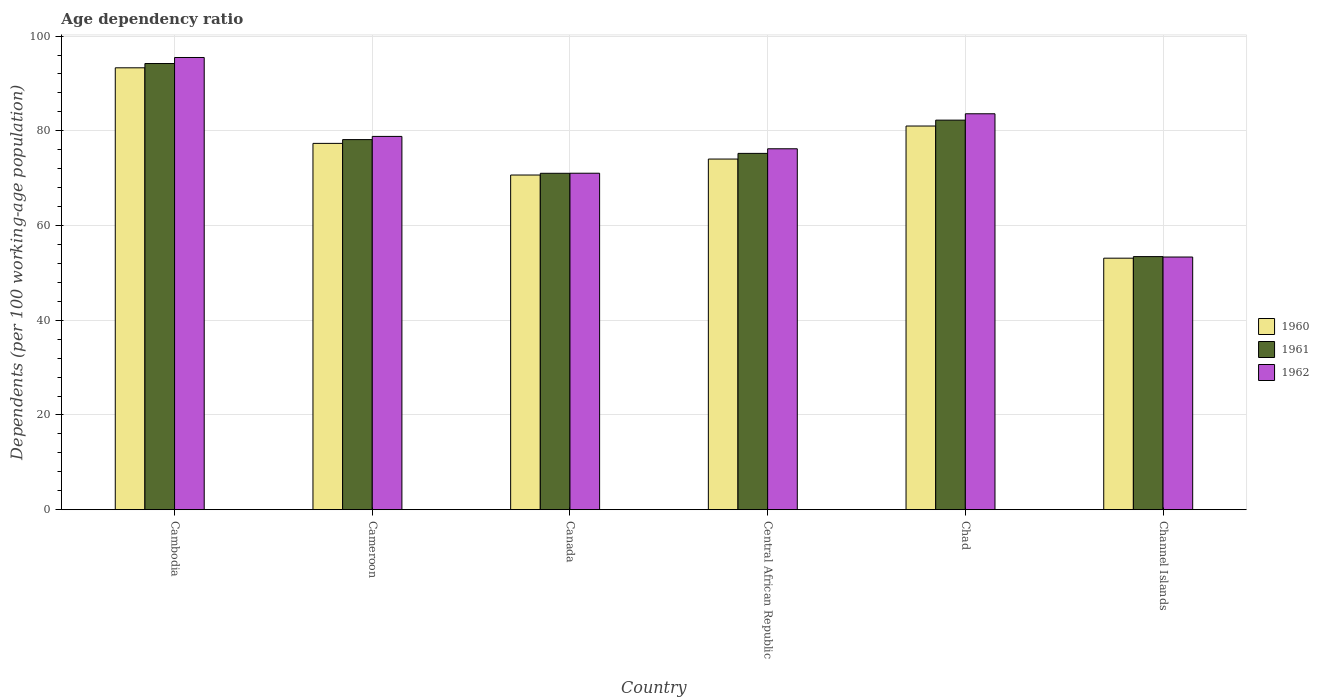How many groups of bars are there?
Ensure brevity in your answer.  6. Are the number of bars per tick equal to the number of legend labels?
Make the answer very short. Yes. How many bars are there on the 2nd tick from the left?
Provide a short and direct response. 3. How many bars are there on the 1st tick from the right?
Your answer should be very brief. 3. What is the label of the 5th group of bars from the left?
Your answer should be very brief. Chad. What is the age dependency ratio in in 1960 in Cambodia?
Your answer should be very brief. 93.3. Across all countries, what is the maximum age dependency ratio in in 1960?
Your answer should be compact. 93.3. Across all countries, what is the minimum age dependency ratio in in 1962?
Ensure brevity in your answer.  53.35. In which country was the age dependency ratio in in 1962 maximum?
Give a very brief answer. Cambodia. In which country was the age dependency ratio in in 1962 minimum?
Your response must be concise. Channel Islands. What is the total age dependency ratio in in 1962 in the graph?
Provide a succinct answer. 458.49. What is the difference between the age dependency ratio in in 1960 in Cambodia and that in Channel Islands?
Provide a succinct answer. 40.2. What is the difference between the age dependency ratio in in 1960 in Cambodia and the age dependency ratio in in 1962 in Canada?
Ensure brevity in your answer.  22.26. What is the average age dependency ratio in in 1962 per country?
Your answer should be very brief. 76.41. What is the difference between the age dependency ratio in of/in 1961 and age dependency ratio in of/in 1962 in Central African Republic?
Your response must be concise. -0.97. In how many countries, is the age dependency ratio in in 1961 greater than 64 %?
Make the answer very short. 5. What is the ratio of the age dependency ratio in in 1961 in Central African Republic to that in Chad?
Provide a succinct answer. 0.91. Is the age dependency ratio in in 1960 in Canada less than that in Chad?
Provide a short and direct response. Yes. What is the difference between the highest and the second highest age dependency ratio in in 1962?
Make the answer very short. 4.78. What is the difference between the highest and the lowest age dependency ratio in in 1962?
Your answer should be very brief. 42.13. Is the sum of the age dependency ratio in in 1961 in Cambodia and Chad greater than the maximum age dependency ratio in in 1960 across all countries?
Your response must be concise. Yes. What does the 2nd bar from the left in Channel Islands represents?
Your answer should be very brief. 1961. Is it the case that in every country, the sum of the age dependency ratio in in 1961 and age dependency ratio in in 1960 is greater than the age dependency ratio in in 1962?
Your answer should be very brief. Yes. Are the values on the major ticks of Y-axis written in scientific E-notation?
Ensure brevity in your answer.  No. How are the legend labels stacked?
Provide a succinct answer. Vertical. What is the title of the graph?
Provide a succinct answer. Age dependency ratio. Does "1961" appear as one of the legend labels in the graph?
Provide a succinct answer. Yes. What is the label or title of the Y-axis?
Make the answer very short. Dependents (per 100 working-age population). What is the Dependents (per 100 working-age population) of 1960 in Cambodia?
Offer a very short reply. 93.3. What is the Dependents (per 100 working-age population) in 1961 in Cambodia?
Offer a terse response. 94.21. What is the Dependents (per 100 working-age population) in 1962 in Cambodia?
Give a very brief answer. 95.48. What is the Dependents (per 100 working-age population) in 1960 in Cameroon?
Give a very brief answer. 77.34. What is the Dependents (per 100 working-age population) in 1961 in Cameroon?
Keep it short and to the point. 78.14. What is the Dependents (per 100 working-age population) of 1962 in Cameroon?
Offer a terse response. 78.82. What is the Dependents (per 100 working-age population) of 1960 in Canada?
Your response must be concise. 70.66. What is the Dependents (per 100 working-age population) in 1961 in Canada?
Offer a very short reply. 71.03. What is the Dependents (per 100 working-age population) of 1962 in Canada?
Your answer should be compact. 71.04. What is the Dependents (per 100 working-age population) of 1960 in Central African Republic?
Provide a short and direct response. 74.03. What is the Dependents (per 100 working-age population) of 1961 in Central African Republic?
Make the answer very short. 75.23. What is the Dependents (per 100 working-age population) in 1962 in Central African Republic?
Offer a very short reply. 76.21. What is the Dependents (per 100 working-age population) of 1960 in Chad?
Provide a succinct answer. 81.01. What is the Dependents (per 100 working-age population) of 1961 in Chad?
Your response must be concise. 82.25. What is the Dependents (per 100 working-age population) of 1962 in Chad?
Provide a short and direct response. 83.6. What is the Dependents (per 100 working-age population) in 1960 in Channel Islands?
Give a very brief answer. 53.1. What is the Dependents (per 100 working-age population) in 1961 in Channel Islands?
Offer a very short reply. 53.44. What is the Dependents (per 100 working-age population) in 1962 in Channel Islands?
Keep it short and to the point. 53.35. Across all countries, what is the maximum Dependents (per 100 working-age population) of 1960?
Keep it short and to the point. 93.3. Across all countries, what is the maximum Dependents (per 100 working-age population) of 1961?
Ensure brevity in your answer.  94.21. Across all countries, what is the maximum Dependents (per 100 working-age population) of 1962?
Your response must be concise. 95.48. Across all countries, what is the minimum Dependents (per 100 working-age population) of 1960?
Provide a succinct answer. 53.1. Across all countries, what is the minimum Dependents (per 100 working-age population) of 1961?
Provide a succinct answer. 53.44. Across all countries, what is the minimum Dependents (per 100 working-age population) in 1962?
Your response must be concise. 53.35. What is the total Dependents (per 100 working-age population) in 1960 in the graph?
Make the answer very short. 449.46. What is the total Dependents (per 100 working-age population) in 1961 in the graph?
Provide a succinct answer. 454.3. What is the total Dependents (per 100 working-age population) in 1962 in the graph?
Make the answer very short. 458.49. What is the difference between the Dependents (per 100 working-age population) in 1960 in Cambodia and that in Cameroon?
Make the answer very short. 15.96. What is the difference between the Dependents (per 100 working-age population) of 1961 in Cambodia and that in Cameroon?
Provide a short and direct response. 16.06. What is the difference between the Dependents (per 100 working-age population) of 1962 in Cambodia and that in Cameroon?
Provide a succinct answer. 16.66. What is the difference between the Dependents (per 100 working-age population) of 1960 in Cambodia and that in Canada?
Offer a very short reply. 22.64. What is the difference between the Dependents (per 100 working-age population) in 1961 in Cambodia and that in Canada?
Offer a terse response. 23.18. What is the difference between the Dependents (per 100 working-age population) in 1962 in Cambodia and that in Canada?
Provide a succinct answer. 24.44. What is the difference between the Dependents (per 100 working-age population) in 1960 in Cambodia and that in Central African Republic?
Your response must be concise. 19.27. What is the difference between the Dependents (per 100 working-age population) of 1961 in Cambodia and that in Central African Republic?
Offer a very short reply. 18.97. What is the difference between the Dependents (per 100 working-age population) of 1962 in Cambodia and that in Central African Republic?
Make the answer very short. 19.28. What is the difference between the Dependents (per 100 working-age population) of 1960 in Cambodia and that in Chad?
Offer a terse response. 12.29. What is the difference between the Dependents (per 100 working-age population) of 1961 in Cambodia and that in Chad?
Provide a succinct answer. 11.95. What is the difference between the Dependents (per 100 working-age population) of 1962 in Cambodia and that in Chad?
Provide a short and direct response. 11.89. What is the difference between the Dependents (per 100 working-age population) in 1960 in Cambodia and that in Channel Islands?
Offer a terse response. 40.2. What is the difference between the Dependents (per 100 working-age population) in 1961 in Cambodia and that in Channel Islands?
Give a very brief answer. 40.76. What is the difference between the Dependents (per 100 working-age population) in 1962 in Cambodia and that in Channel Islands?
Offer a very short reply. 42.13. What is the difference between the Dependents (per 100 working-age population) in 1960 in Cameroon and that in Canada?
Offer a very short reply. 6.68. What is the difference between the Dependents (per 100 working-age population) of 1961 in Cameroon and that in Canada?
Offer a terse response. 7.12. What is the difference between the Dependents (per 100 working-age population) in 1962 in Cameroon and that in Canada?
Provide a short and direct response. 7.77. What is the difference between the Dependents (per 100 working-age population) in 1960 in Cameroon and that in Central African Republic?
Your response must be concise. 3.31. What is the difference between the Dependents (per 100 working-age population) of 1961 in Cameroon and that in Central African Republic?
Offer a very short reply. 2.91. What is the difference between the Dependents (per 100 working-age population) of 1962 in Cameroon and that in Central African Republic?
Provide a short and direct response. 2.61. What is the difference between the Dependents (per 100 working-age population) of 1960 in Cameroon and that in Chad?
Offer a very short reply. -3.67. What is the difference between the Dependents (per 100 working-age population) in 1961 in Cameroon and that in Chad?
Provide a short and direct response. -4.11. What is the difference between the Dependents (per 100 working-age population) of 1962 in Cameroon and that in Chad?
Offer a very short reply. -4.78. What is the difference between the Dependents (per 100 working-age population) of 1960 in Cameroon and that in Channel Islands?
Offer a terse response. 24.24. What is the difference between the Dependents (per 100 working-age population) of 1961 in Cameroon and that in Channel Islands?
Your answer should be very brief. 24.7. What is the difference between the Dependents (per 100 working-age population) of 1962 in Cameroon and that in Channel Islands?
Offer a very short reply. 25.47. What is the difference between the Dependents (per 100 working-age population) in 1960 in Canada and that in Central African Republic?
Your answer should be compact. -3.37. What is the difference between the Dependents (per 100 working-age population) in 1961 in Canada and that in Central African Republic?
Ensure brevity in your answer.  -4.2. What is the difference between the Dependents (per 100 working-age population) in 1962 in Canada and that in Central African Republic?
Give a very brief answer. -5.16. What is the difference between the Dependents (per 100 working-age population) in 1960 in Canada and that in Chad?
Offer a very short reply. -10.35. What is the difference between the Dependents (per 100 working-age population) of 1961 in Canada and that in Chad?
Your answer should be very brief. -11.22. What is the difference between the Dependents (per 100 working-age population) in 1962 in Canada and that in Chad?
Ensure brevity in your answer.  -12.55. What is the difference between the Dependents (per 100 working-age population) of 1960 in Canada and that in Channel Islands?
Offer a very short reply. 17.56. What is the difference between the Dependents (per 100 working-age population) in 1961 in Canada and that in Channel Islands?
Offer a terse response. 17.59. What is the difference between the Dependents (per 100 working-age population) in 1962 in Canada and that in Channel Islands?
Your response must be concise. 17.69. What is the difference between the Dependents (per 100 working-age population) of 1960 in Central African Republic and that in Chad?
Your answer should be compact. -6.97. What is the difference between the Dependents (per 100 working-age population) of 1961 in Central African Republic and that in Chad?
Your answer should be compact. -7.02. What is the difference between the Dependents (per 100 working-age population) in 1962 in Central African Republic and that in Chad?
Offer a very short reply. -7.39. What is the difference between the Dependents (per 100 working-age population) in 1960 in Central African Republic and that in Channel Islands?
Provide a succinct answer. 20.93. What is the difference between the Dependents (per 100 working-age population) of 1961 in Central African Republic and that in Channel Islands?
Offer a terse response. 21.79. What is the difference between the Dependents (per 100 working-age population) of 1962 in Central African Republic and that in Channel Islands?
Give a very brief answer. 22.86. What is the difference between the Dependents (per 100 working-age population) in 1960 in Chad and that in Channel Islands?
Your answer should be compact. 27.91. What is the difference between the Dependents (per 100 working-age population) of 1961 in Chad and that in Channel Islands?
Give a very brief answer. 28.81. What is the difference between the Dependents (per 100 working-age population) of 1962 in Chad and that in Channel Islands?
Keep it short and to the point. 30.25. What is the difference between the Dependents (per 100 working-age population) of 1960 in Cambodia and the Dependents (per 100 working-age population) of 1961 in Cameroon?
Provide a succinct answer. 15.16. What is the difference between the Dependents (per 100 working-age population) of 1960 in Cambodia and the Dependents (per 100 working-age population) of 1962 in Cameroon?
Your answer should be very brief. 14.49. What is the difference between the Dependents (per 100 working-age population) of 1961 in Cambodia and the Dependents (per 100 working-age population) of 1962 in Cameroon?
Your answer should be compact. 15.39. What is the difference between the Dependents (per 100 working-age population) in 1960 in Cambodia and the Dependents (per 100 working-age population) in 1961 in Canada?
Keep it short and to the point. 22.27. What is the difference between the Dependents (per 100 working-age population) of 1960 in Cambodia and the Dependents (per 100 working-age population) of 1962 in Canada?
Keep it short and to the point. 22.26. What is the difference between the Dependents (per 100 working-age population) in 1961 in Cambodia and the Dependents (per 100 working-age population) in 1962 in Canada?
Make the answer very short. 23.16. What is the difference between the Dependents (per 100 working-age population) of 1960 in Cambodia and the Dependents (per 100 working-age population) of 1961 in Central African Republic?
Provide a succinct answer. 18.07. What is the difference between the Dependents (per 100 working-age population) in 1960 in Cambodia and the Dependents (per 100 working-age population) in 1962 in Central African Republic?
Offer a very short reply. 17.1. What is the difference between the Dependents (per 100 working-age population) in 1960 in Cambodia and the Dependents (per 100 working-age population) in 1961 in Chad?
Make the answer very short. 11.05. What is the difference between the Dependents (per 100 working-age population) in 1960 in Cambodia and the Dependents (per 100 working-age population) in 1962 in Chad?
Your response must be concise. 9.71. What is the difference between the Dependents (per 100 working-age population) in 1961 in Cambodia and the Dependents (per 100 working-age population) in 1962 in Chad?
Ensure brevity in your answer.  10.61. What is the difference between the Dependents (per 100 working-age population) of 1960 in Cambodia and the Dependents (per 100 working-age population) of 1961 in Channel Islands?
Offer a very short reply. 39.86. What is the difference between the Dependents (per 100 working-age population) in 1960 in Cambodia and the Dependents (per 100 working-age population) in 1962 in Channel Islands?
Your answer should be compact. 39.95. What is the difference between the Dependents (per 100 working-age population) in 1961 in Cambodia and the Dependents (per 100 working-age population) in 1962 in Channel Islands?
Offer a terse response. 40.86. What is the difference between the Dependents (per 100 working-age population) of 1960 in Cameroon and the Dependents (per 100 working-age population) of 1961 in Canada?
Keep it short and to the point. 6.32. What is the difference between the Dependents (per 100 working-age population) of 1960 in Cameroon and the Dependents (per 100 working-age population) of 1962 in Canada?
Keep it short and to the point. 6.3. What is the difference between the Dependents (per 100 working-age population) of 1961 in Cameroon and the Dependents (per 100 working-age population) of 1962 in Canada?
Offer a terse response. 7.1. What is the difference between the Dependents (per 100 working-age population) in 1960 in Cameroon and the Dependents (per 100 working-age population) in 1961 in Central African Republic?
Provide a short and direct response. 2.11. What is the difference between the Dependents (per 100 working-age population) of 1960 in Cameroon and the Dependents (per 100 working-age population) of 1962 in Central African Republic?
Your answer should be very brief. 1.14. What is the difference between the Dependents (per 100 working-age population) of 1961 in Cameroon and the Dependents (per 100 working-age population) of 1962 in Central African Republic?
Keep it short and to the point. 1.94. What is the difference between the Dependents (per 100 working-age population) of 1960 in Cameroon and the Dependents (per 100 working-age population) of 1961 in Chad?
Your answer should be compact. -4.91. What is the difference between the Dependents (per 100 working-age population) of 1960 in Cameroon and the Dependents (per 100 working-age population) of 1962 in Chad?
Ensure brevity in your answer.  -6.25. What is the difference between the Dependents (per 100 working-age population) of 1961 in Cameroon and the Dependents (per 100 working-age population) of 1962 in Chad?
Your answer should be compact. -5.45. What is the difference between the Dependents (per 100 working-age population) in 1960 in Cameroon and the Dependents (per 100 working-age population) in 1961 in Channel Islands?
Give a very brief answer. 23.9. What is the difference between the Dependents (per 100 working-age population) of 1960 in Cameroon and the Dependents (per 100 working-age population) of 1962 in Channel Islands?
Your response must be concise. 24. What is the difference between the Dependents (per 100 working-age population) of 1961 in Cameroon and the Dependents (per 100 working-age population) of 1962 in Channel Islands?
Offer a terse response. 24.8. What is the difference between the Dependents (per 100 working-age population) in 1960 in Canada and the Dependents (per 100 working-age population) in 1961 in Central African Republic?
Give a very brief answer. -4.57. What is the difference between the Dependents (per 100 working-age population) in 1960 in Canada and the Dependents (per 100 working-age population) in 1962 in Central African Republic?
Your answer should be compact. -5.54. What is the difference between the Dependents (per 100 working-age population) of 1961 in Canada and the Dependents (per 100 working-age population) of 1962 in Central African Republic?
Provide a succinct answer. -5.18. What is the difference between the Dependents (per 100 working-age population) of 1960 in Canada and the Dependents (per 100 working-age population) of 1961 in Chad?
Make the answer very short. -11.59. What is the difference between the Dependents (per 100 working-age population) of 1960 in Canada and the Dependents (per 100 working-age population) of 1962 in Chad?
Ensure brevity in your answer.  -12.93. What is the difference between the Dependents (per 100 working-age population) of 1961 in Canada and the Dependents (per 100 working-age population) of 1962 in Chad?
Your answer should be very brief. -12.57. What is the difference between the Dependents (per 100 working-age population) of 1960 in Canada and the Dependents (per 100 working-age population) of 1961 in Channel Islands?
Your answer should be compact. 17.22. What is the difference between the Dependents (per 100 working-age population) in 1960 in Canada and the Dependents (per 100 working-age population) in 1962 in Channel Islands?
Make the answer very short. 17.31. What is the difference between the Dependents (per 100 working-age population) in 1961 in Canada and the Dependents (per 100 working-age population) in 1962 in Channel Islands?
Provide a short and direct response. 17.68. What is the difference between the Dependents (per 100 working-age population) in 1960 in Central African Republic and the Dependents (per 100 working-age population) in 1961 in Chad?
Your response must be concise. -8.22. What is the difference between the Dependents (per 100 working-age population) in 1960 in Central African Republic and the Dependents (per 100 working-age population) in 1962 in Chad?
Offer a terse response. -9.56. What is the difference between the Dependents (per 100 working-age population) in 1961 in Central African Republic and the Dependents (per 100 working-age population) in 1962 in Chad?
Your answer should be very brief. -8.36. What is the difference between the Dependents (per 100 working-age population) in 1960 in Central African Republic and the Dependents (per 100 working-age population) in 1961 in Channel Islands?
Your answer should be compact. 20.59. What is the difference between the Dependents (per 100 working-age population) of 1960 in Central African Republic and the Dependents (per 100 working-age population) of 1962 in Channel Islands?
Give a very brief answer. 20.69. What is the difference between the Dependents (per 100 working-age population) of 1961 in Central African Republic and the Dependents (per 100 working-age population) of 1962 in Channel Islands?
Make the answer very short. 21.88. What is the difference between the Dependents (per 100 working-age population) in 1960 in Chad and the Dependents (per 100 working-age population) in 1961 in Channel Islands?
Provide a short and direct response. 27.57. What is the difference between the Dependents (per 100 working-age population) of 1960 in Chad and the Dependents (per 100 working-age population) of 1962 in Channel Islands?
Give a very brief answer. 27.66. What is the difference between the Dependents (per 100 working-age population) in 1961 in Chad and the Dependents (per 100 working-age population) in 1962 in Channel Islands?
Offer a very short reply. 28.9. What is the average Dependents (per 100 working-age population) in 1960 per country?
Your response must be concise. 74.91. What is the average Dependents (per 100 working-age population) of 1961 per country?
Your answer should be compact. 75.72. What is the average Dependents (per 100 working-age population) in 1962 per country?
Ensure brevity in your answer.  76.41. What is the difference between the Dependents (per 100 working-age population) of 1960 and Dependents (per 100 working-age population) of 1961 in Cambodia?
Your answer should be very brief. -0.9. What is the difference between the Dependents (per 100 working-age population) in 1960 and Dependents (per 100 working-age population) in 1962 in Cambodia?
Provide a short and direct response. -2.18. What is the difference between the Dependents (per 100 working-age population) of 1961 and Dependents (per 100 working-age population) of 1962 in Cambodia?
Your response must be concise. -1.28. What is the difference between the Dependents (per 100 working-age population) in 1960 and Dependents (per 100 working-age population) in 1961 in Cameroon?
Provide a succinct answer. -0.8. What is the difference between the Dependents (per 100 working-age population) of 1960 and Dependents (per 100 working-age population) of 1962 in Cameroon?
Your answer should be compact. -1.47. What is the difference between the Dependents (per 100 working-age population) in 1961 and Dependents (per 100 working-age population) in 1962 in Cameroon?
Your answer should be compact. -0.67. What is the difference between the Dependents (per 100 working-age population) in 1960 and Dependents (per 100 working-age population) in 1961 in Canada?
Keep it short and to the point. -0.37. What is the difference between the Dependents (per 100 working-age population) of 1960 and Dependents (per 100 working-age population) of 1962 in Canada?
Provide a succinct answer. -0.38. What is the difference between the Dependents (per 100 working-age population) of 1961 and Dependents (per 100 working-age population) of 1962 in Canada?
Provide a succinct answer. -0.01. What is the difference between the Dependents (per 100 working-age population) of 1960 and Dependents (per 100 working-age population) of 1961 in Central African Republic?
Your answer should be very brief. -1.2. What is the difference between the Dependents (per 100 working-age population) in 1960 and Dependents (per 100 working-age population) in 1962 in Central African Republic?
Your response must be concise. -2.17. What is the difference between the Dependents (per 100 working-age population) in 1961 and Dependents (per 100 working-age population) in 1962 in Central African Republic?
Your response must be concise. -0.97. What is the difference between the Dependents (per 100 working-age population) in 1960 and Dependents (per 100 working-age population) in 1961 in Chad?
Your answer should be compact. -1.24. What is the difference between the Dependents (per 100 working-age population) in 1960 and Dependents (per 100 working-age population) in 1962 in Chad?
Make the answer very short. -2.59. What is the difference between the Dependents (per 100 working-age population) of 1961 and Dependents (per 100 working-age population) of 1962 in Chad?
Offer a very short reply. -1.34. What is the difference between the Dependents (per 100 working-age population) of 1960 and Dependents (per 100 working-age population) of 1961 in Channel Islands?
Your answer should be very brief. -0.34. What is the difference between the Dependents (per 100 working-age population) in 1960 and Dependents (per 100 working-age population) in 1962 in Channel Islands?
Your answer should be compact. -0.24. What is the difference between the Dependents (per 100 working-age population) of 1961 and Dependents (per 100 working-age population) of 1962 in Channel Islands?
Offer a very short reply. 0.09. What is the ratio of the Dependents (per 100 working-age population) of 1960 in Cambodia to that in Cameroon?
Offer a very short reply. 1.21. What is the ratio of the Dependents (per 100 working-age population) in 1961 in Cambodia to that in Cameroon?
Give a very brief answer. 1.21. What is the ratio of the Dependents (per 100 working-age population) in 1962 in Cambodia to that in Cameroon?
Your answer should be compact. 1.21. What is the ratio of the Dependents (per 100 working-age population) of 1960 in Cambodia to that in Canada?
Offer a very short reply. 1.32. What is the ratio of the Dependents (per 100 working-age population) of 1961 in Cambodia to that in Canada?
Your answer should be very brief. 1.33. What is the ratio of the Dependents (per 100 working-age population) in 1962 in Cambodia to that in Canada?
Give a very brief answer. 1.34. What is the ratio of the Dependents (per 100 working-age population) in 1960 in Cambodia to that in Central African Republic?
Give a very brief answer. 1.26. What is the ratio of the Dependents (per 100 working-age population) in 1961 in Cambodia to that in Central African Republic?
Ensure brevity in your answer.  1.25. What is the ratio of the Dependents (per 100 working-age population) of 1962 in Cambodia to that in Central African Republic?
Your answer should be very brief. 1.25. What is the ratio of the Dependents (per 100 working-age population) in 1960 in Cambodia to that in Chad?
Provide a succinct answer. 1.15. What is the ratio of the Dependents (per 100 working-age population) of 1961 in Cambodia to that in Chad?
Offer a terse response. 1.15. What is the ratio of the Dependents (per 100 working-age population) of 1962 in Cambodia to that in Chad?
Give a very brief answer. 1.14. What is the ratio of the Dependents (per 100 working-age population) in 1960 in Cambodia to that in Channel Islands?
Give a very brief answer. 1.76. What is the ratio of the Dependents (per 100 working-age population) of 1961 in Cambodia to that in Channel Islands?
Your answer should be very brief. 1.76. What is the ratio of the Dependents (per 100 working-age population) in 1962 in Cambodia to that in Channel Islands?
Make the answer very short. 1.79. What is the ratio of the Dependents (per 100 working-age population) of 1960 in Cameroon to that in Canada?
Make the answer very short. 1.09. What is the ratio of the Dependents (per 100 working-age population) in 1961 in Cameroon to that in Canada?
Ensure brevity in your answer.  1.1. What is the ratio of the Dependents (per 100 working-age population) of 1962 in Cameroon to that in Canada?
Provide a succinct answer. 1.11. What is the ratio of the Dependents (per 100 working-age population) of 1960 in Cameroon to that in Central African Republic?
Your answer should be very brief. 1.04. What is the ratio of the Dependents (per 100 working-age population) of 1961 in Cameroon to that in Central African Republic?
Offer a terse response. 1.04. What is the ratio of the Dependents (per 100 working-age population) of 1962 in Cameroon to that in Central African Republic?
Offer a terse response. 1.03. What is the ratio of the Dependents (per 100 working-age population) of 1960 in Cameroon to that in Chad?
Ensure brevity in your answer.  0.95. What is the ratio of the Dependents (per 100 working-age population) of 1961 in Cameroon to that in Chad?
Give a very brief answer. 0.95. What is the ratio of the Dependents (per 100 working-age population) of 1962 in Cameroon to that in Chad?
Your answer should be very brief. 0.94. What is the ratio of the Dependents (per 100 working-age population) in 1960 in Cameroon to that in Channel Islands?
Provide a succinct answer. 1.46. What is the ratio of the Dependents (per 100 working-age population) in 1961 in Cameroon to that in Channel Islands?
Provide a short and direct response. 1.46. What is the ratio of the Dependents (per 100 working-age population) of 1962 in Cameroon to that in Channel Islands?
Your answer should be compact. 1.48. What is the ratio of the Dependents (per 100 working-age population) of 1960 in Canada to that in Central African Republic?
Give a very brief answer. 0.95. What is the ratio of the Dependents (per 100 working-age population) of 1961 in Canada to that in Central African Republic?
Give a very brief answer. 0.94. What is the ratio of the Dependents (per 100 working-age population) in 1962 in Canada to that in Central African Republic?
Keep it short and to the point. 0.93. What is the ratio of the Dependents (per 100 working-age population) of 1960 in Canada to that in Chad?
Offer a terse response. 0.87. What is the ratio of the Dependents (per 100 working-age population) in 1961 in Canada to that in Chad?
Provide a succinct answer. 0.86. What is the ratio of the Dependents (per 100 working-age population) of 1962 in Canada to that in Chad?
Provide a succinct answer. 0.85. What is the ratio of the Dependents (per 100 working-age population) in 1960 in Canada to that in Channel Islands?
Offer a very short reply. 1.33. What is the ratio of the Dependents (per 100 working-age population) in 1961 in Canada to that in Channel Islands?
Give a very brief answer. 1.33. What is the ratio of the Dependents (per 100 working-age population) of 1962 in Canada to that in Channel Islands?
Your answer should be compact. 1.33. What is the ratio of the Dependents (per 100 working-age population) in 1960 in Central African Republic to that in Chad?
Provide a short and direct response. 0.91. What is the ratio of the Dependents (per 100 working-age population) in 1961 in Central African Republic to that in Chad?
Ensure brevity in your answer.  0.91. What is the ratio of the Dependents (per 100 working-age population) in 1962 in Central African Republic to that in Chad?
Offer a terse response. 0.91. What is the ratio of the Dependents (per 100 working-age population) of 1960 in Central African Republic to that in Channel Islands?
Offer a very short reply. 1.39. What is the ratio of the Dependents (per 100 working-age population) in 1961 in Central African Republic to that in Channel Islands?
Ensure brevity in your answer.  1.41. What is the ratio of the Dependents (per 100 working-age population) in 1962 in Central African Republic to that in Channel Islands?
Your answer should be compact. 1.43. What is the ratio of the Dependents (per 100 working-age population) in 1960 in Chad to that in Channel Islands?
Keep it short and to the point. 1.53. What is the ratio of the Dependents (per 100 working-age population) in 1961 in Chad to that in Channel Islands?
Your answer should be compact. 1.54. What is the ratio of the Dependents (per 100 working-age population) of 1962 in Chad to that in Channel Islands?
Make the answer very short. 1.57. What is the difference between the highest and the second highest Dependents (per 100 working-age population) in 1960?
Keep it short and to the point. 12.29. What is the difference between the highest and the second highest Dependents (per 100 working-age population) in 1961?
Give a very brief answer. 11.95. What is the difference between the highest and the second highest Dependents (per 100 working-age population) in 1962?
Your answer should be very brief. 11.89. What is the difference between the highest and the lowest Dependents (per 100 working-age population) in 1960?
Offer a terse response. 40.2. What is the difference between the highest and the lowest Dependents (per 100 working-age population) of 1961?
Provide a short and direct response. 40.76. What is the difference between the highest and the lowest Dependents (per 100 working-age population) in 1962?
Ensure brevity in your answer.  42.13. 